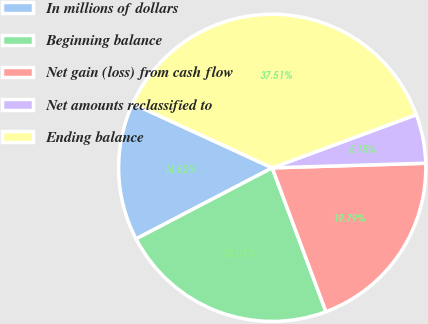<chart> <loc_0><loc_0><loc_500><loc_500><pie_chart><fcel>In millions of dollars<fcel>Beginning balance<fcel>Net gain (loss) from cash flow<fcel>Net amounts reclassified to<fcel>Ending balance<nl><fcel>14.52%<fcel>23.03%<fcel>19.79%<fcel>5.15%<fcel>37.51%<nl></chart> 